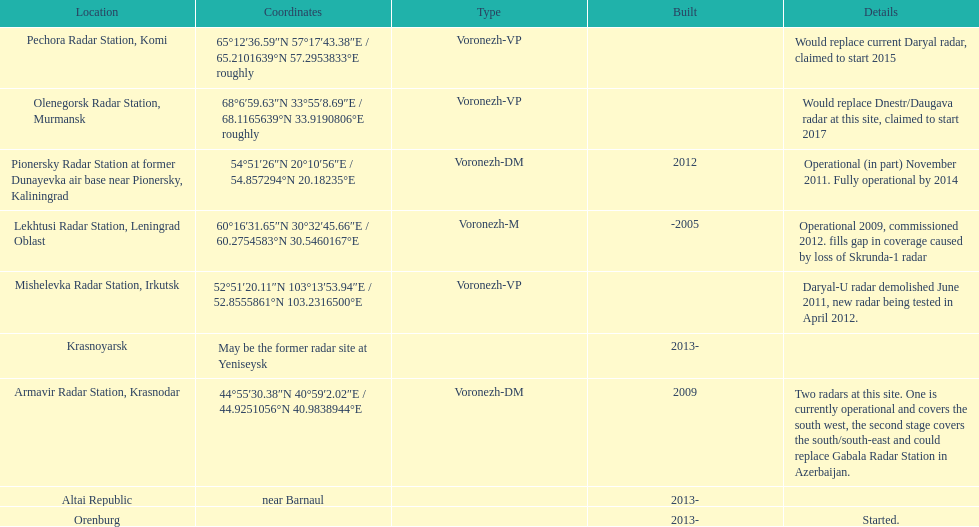What is the only location with a coordination of 60°16&#8242;31.65&#8243;n 30°32&#8242;45.66&#8243;e / 60.2754583°n 30.5460167°e? Lekhtusi Radar Station, Leningrad Oblast. 